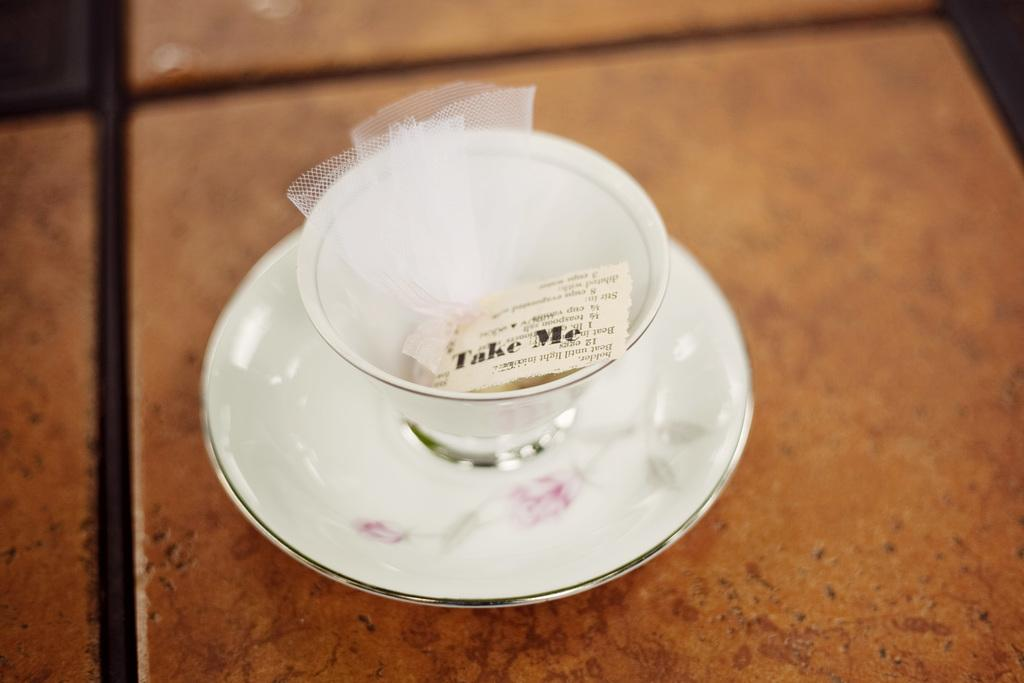What is inside the cup that is visible in the image? The cup contains a paper with text. What else can be seen in the image besides the cup? There is a net placed on a saucer in the image. Where is the saucer located in the image? The saucer is on a surface. How does the spoon help the net play in the image? There is no spoon present in the image, and the net is not shown playing. 